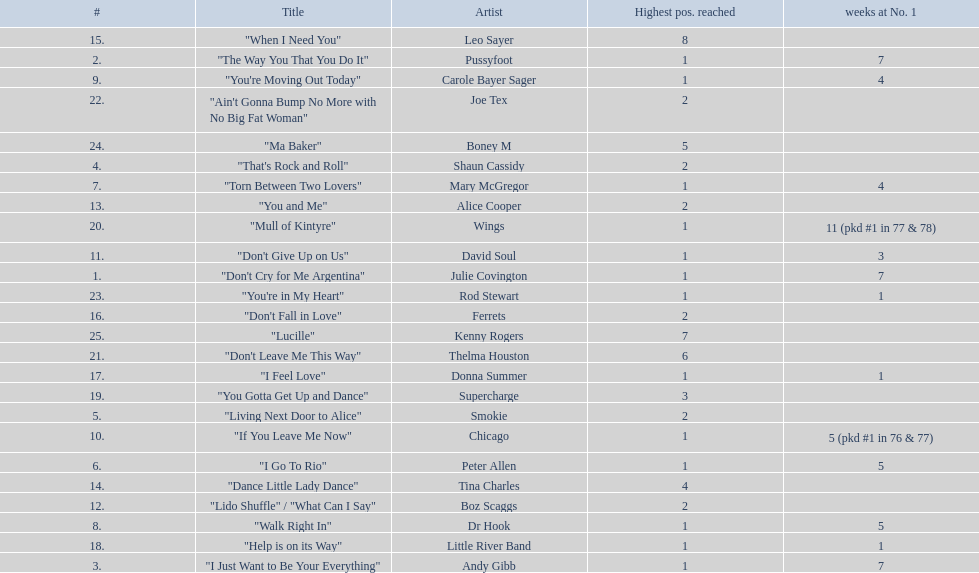How long is the longest amount of time spent at number 1? 11 (pkd #1 in 77 & 78). What song spent 11 weeks at number 1? "Mull of Kintyre". Parse the table in full. {'header': ['#', 'Title', 'Artist', 'Highest pos. reached', 'weeks at No. 1'], 'rows': [['15.', '"When I Need You"', 'Leo Sayer', '8', ''], ['2.', '"The Way You That You Do It"', 'Pussyfoot', '1', '7'], ['9.', '"You\'re Moving Out Today"', 'Carole Bayer Sager', '1', '4'], ['22.', '"Ain\'t Gonna Bump No More with No Big Fat Woman"', 'Joe Tex', '2', ''], ['24.', '"Ma Baker"', 'Boney M', '5', ''], ['4.', '"That\'s Rock and Roll"', 'Shaun Cassidy', '2', ''], ['7.', '"Torn Between Two Lovers"', 'Mary McGregor', '1', '4'], ['13.', '"You and Me"', 'Alice Cooper', '2', ''], ['20.', '"Mull of Kintyre"', 'Wings', '1', '11 (pkd #1 in 77 & 78)'], ['11.', '"Don\'t Give Up on Us"', 'David Soul', '1', '3'], ['1.', '"Don\'t Cry for Me Argentina"', 'Julie Covington', '1', '7'], ['23.', '"You\'re in My Heart"', 'Rod Stewart', '1', '1'], ['16.', '"Don\'t Fall in Love"', 'Ferrets', '2', ''], ['25.', '"Lucille"', 'Kenny Rogers', '7', ''], ['21.', '"Don\'t Leave Me This Way"', 'Thelma Houston', '6', ''], ['17.', '"I Feel Love"', 'Donna Summer', '1', '1'], ['19.', '"You Gotta Get Up and Dance"', 'Supercharge', '3', ''], ['5.', '"Living Next Door to Alice"', 'Smokie', '2', ''], ['10.', '"If You Leave Me Now"', 'Chicago', '1', '5 (pkd #1 in 76 & 77)'], ['6.', '"I Go To Rio"', 'Peter Allen', '1', '5'], ['14.', '"Dance Little Lady Dance"', 'Tina Charles', '4', ''], ['12.', '"Lido Shuffle" / "What Can I Say"', 'Boz Scaggs', '2', ''], ['8.', '"Walk Right In"', 'Dr Hook', '1', '5'], ['18.', '"Help is on its Way"', 'Little River Band', '1', '1'], ['3.', '"I Just Want to Be Your Everything"', 'Andy Gibb', '1', '7']]} What band had a number 1 hit with this song? Wings. 